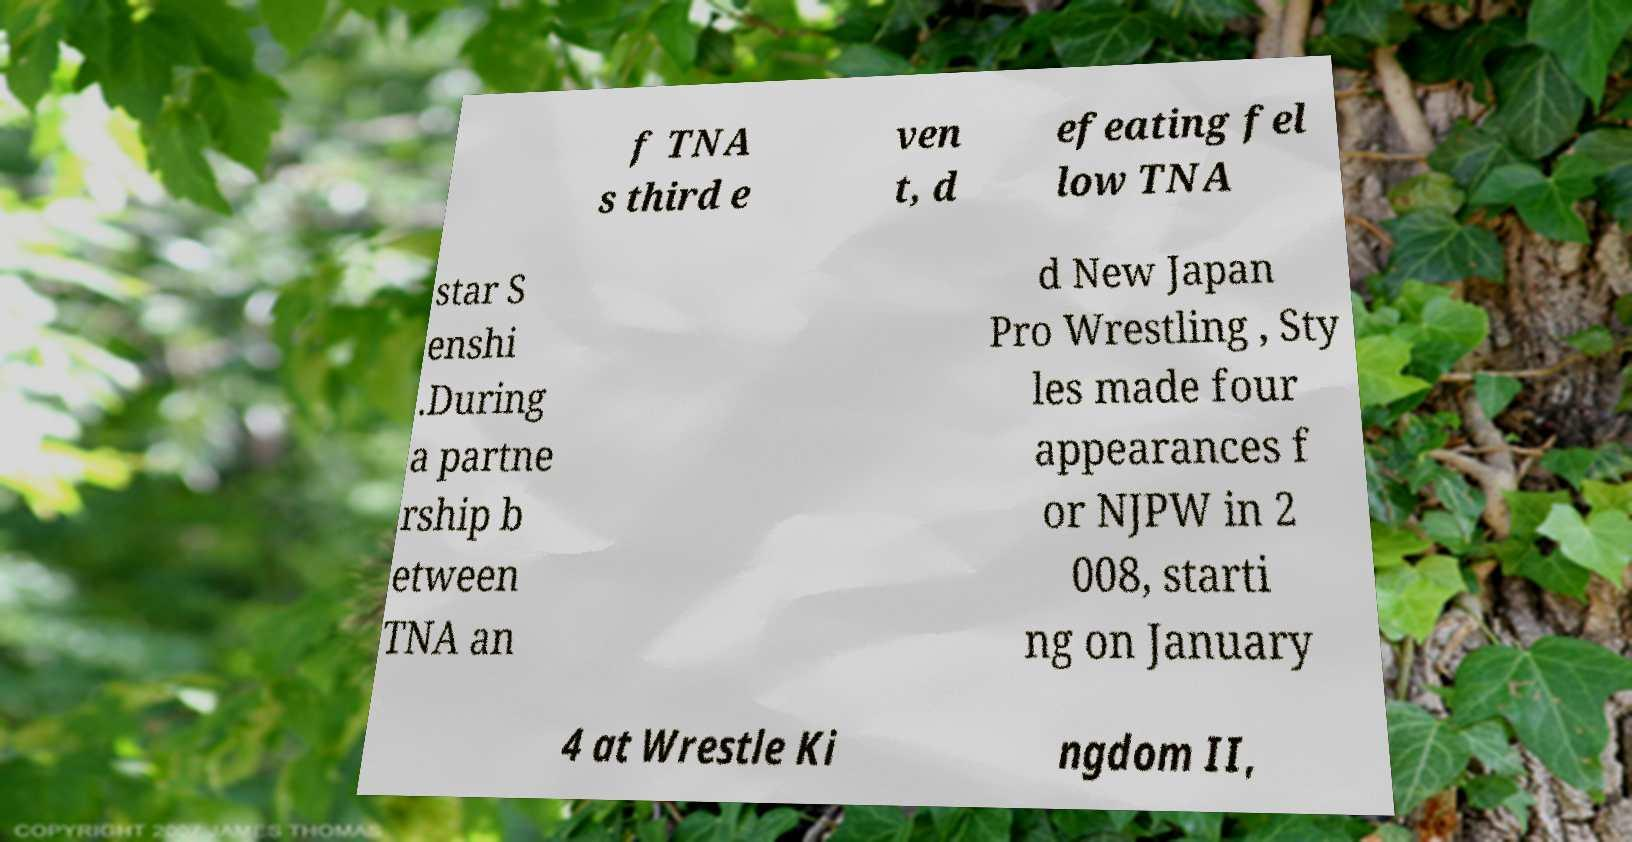I need the written content from this picture converted into text. Can you do that? f TNA s third e ven t, d efeating fel low TNA star S enshi .During a partne rship b etween TNA an d New Japan Pro Wrestling , Sty les made four appearances f or NJPW in 2 008, starti ng on January 4 at Wrestle Ki ngdom II, 